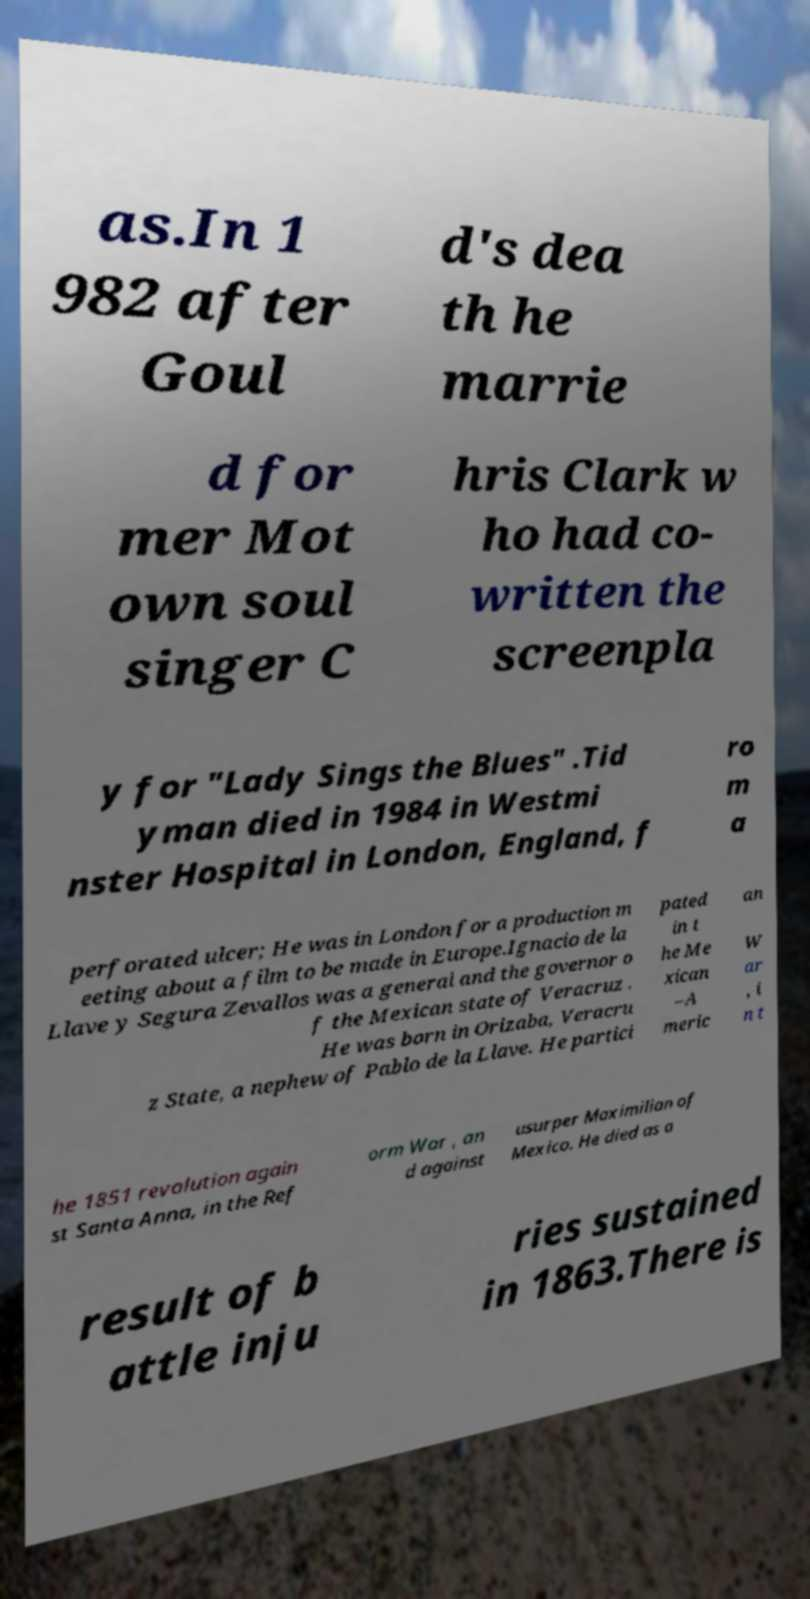Could you extract and type out the text from this image? as.In 1 982 after Goul d's dea th he marrie d for mer Mot own soul singer C hris Clark w ho had co- written the screenpla y for "Lady Sings the Blues" .Tid yman died in 1984 in Westmi nster Hospital in London, England, f ro m a perforated ulcer; He was in London for a production m eeting about a film to be made in Europe.Ignacio de la Llave y Segura Zevallos was a general and the governor o f the Mexican state of Veracruz . He was born in Orizaba, Veracru z State, a nephew of Pablo de la Llave. He partici pated in t he Me xican –A meric an W ar , i n t he 1851 revolution again st Santa Anna, in the Ref orm War , an d against usurper Maximilian of Mexico. He died as a result of b attle inju ries sustained in 1863.There is 